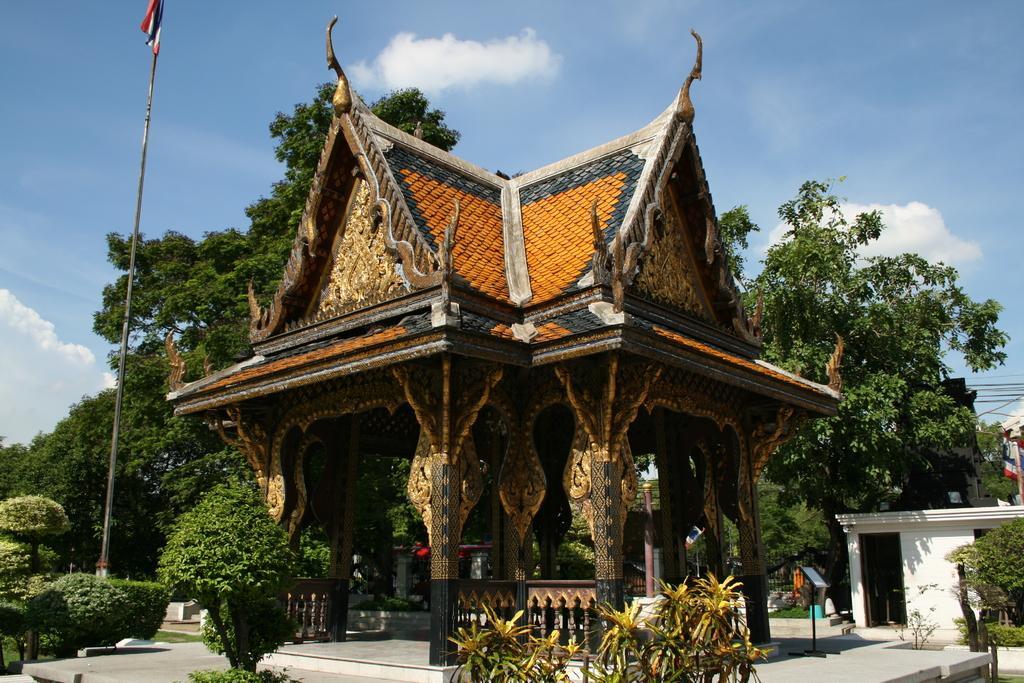How would you summarize this image in a sentence or two? In this image I can see a museum. In the background, I can see trees and clouds in the sky. 